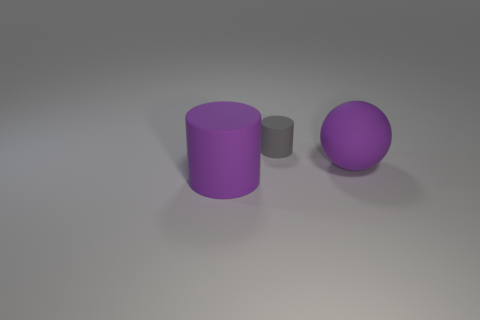There is a big purple matte object that is behind the large purple cylinder; is there a big purple cylinder that is behind it? no 